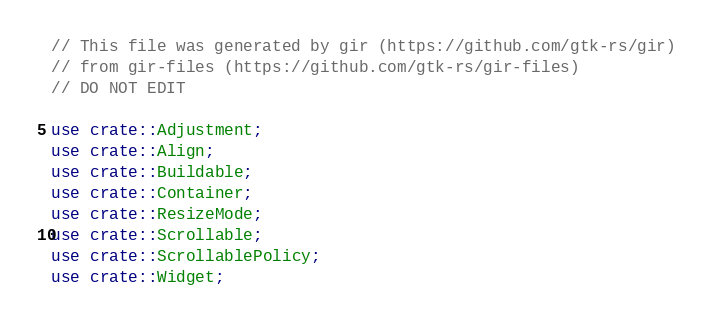<code> <loc_0><loc_0><loc_500><loc_500><_Rust_>// This file was generated by gir (https://github.com/gtk-rs/gir)
// from gir-files (https://github.com/gtk-rs/gir-files)
// DO NOT EDIT

use crate::Adjustment;
use crate::Align;
use crate::Buildable;
use crate::Container;
use crate::ResizeMode;
use crate::Scrollable;
use crate::ScrollablePolicy;
use crate::Widget;</code> 